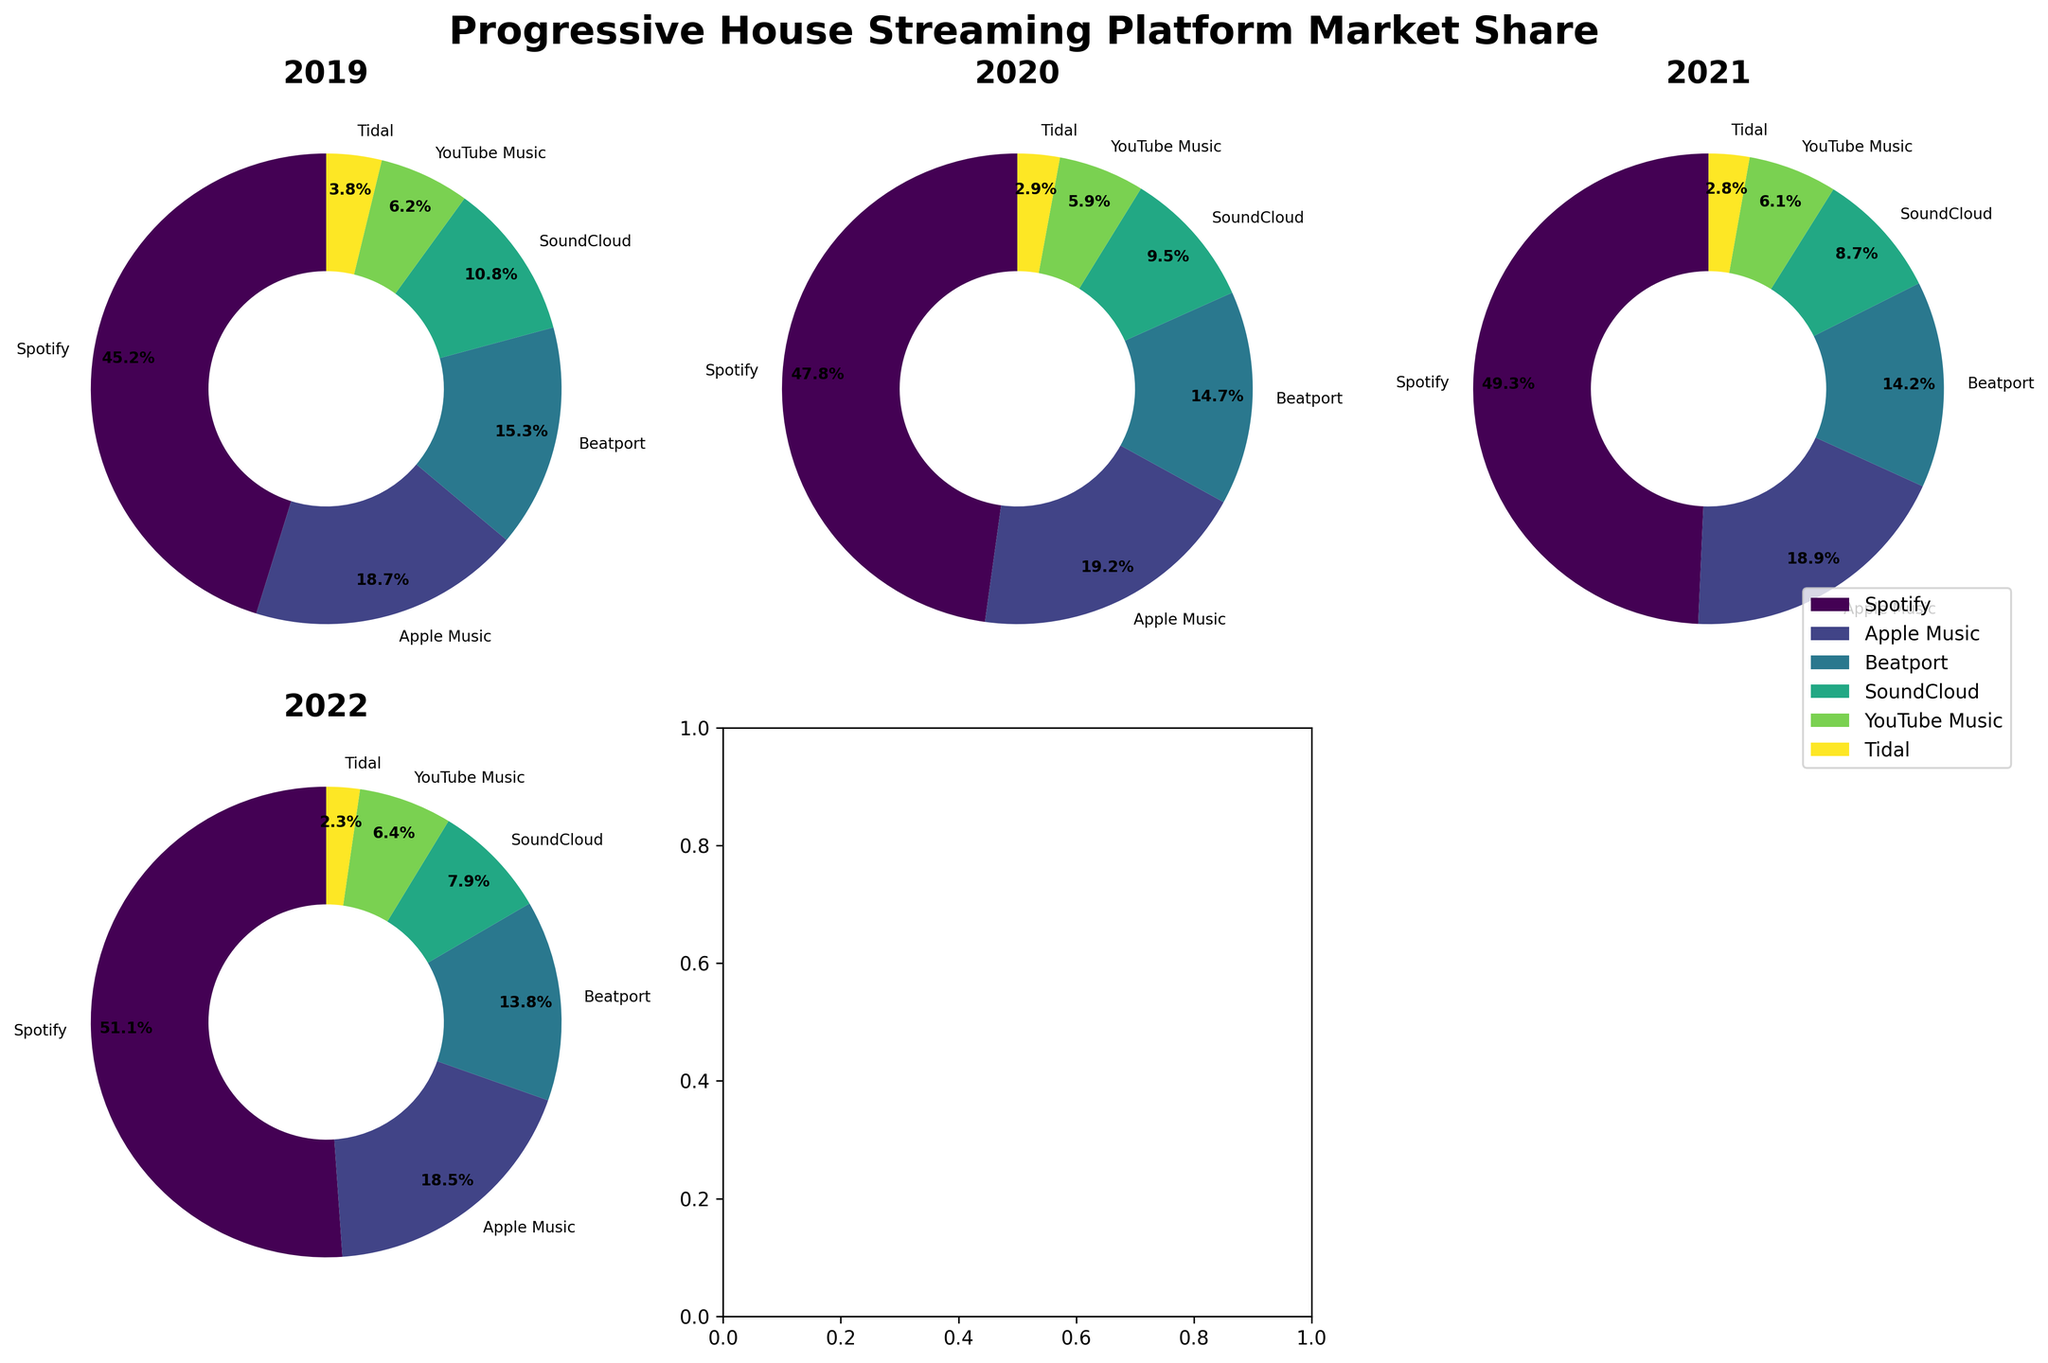How many platforms are displayed in each pie chart? Each pie chart has wedges corresponding to each platform. There are six labels around the pie charts, one for each platform.
Answer: Six Which year shows Spotify with the highest market share? Observing the title of each subplot and the wedge sizes, it's clear that Spotify has the largest wedge in the 2022 subplot.
Answer: 2022 Which platform shows a consistent decrease in market share over the years? By examining each subplot from 2019 to 2022, one can see that SoundCloud has wedges that decrease in size each year.
Answer: SoundCloud How much did Apple Music's market share change from 2019 to 2022? The market share for Apple Music in 2019 was 18.7%, and in 2022 it was 18.5%. The change is calculated by subtracting the latter from the former.
Answer: -0.2% Compare the market share of Tidal in 2019 and 2022, which year had a higher share? Observing the size of Tidal's wedges in the 2019 and 2022 subplots, it's clear that Tidal's wedge is larger in 2019.
Answer: 2019 Which platform has the smallest market share in 2022? Observing the wedges in the 2022 subplot, Tidal has the smallest wedge.
Answer: Tidal What is the trend for Beatport's market share from 2019 to 2022? Observing the pie charts, Beatport’s wedge size decreases every year from 2019 to 2022.
Answer: Decreasing What is the market share percentage difference between YouTube Music in 2019 and 2022? YouTube Music had a market share of 6.2% in 2019 and 6.4% in 2022. The difference is 6.4% - 6.2%.
Answer: 0.2% Which platform’s market share has remained relatively stable from 2019 to 2022? By carefully comparing the pie charts, Apple Music's wedges appear to have the least change in size over the years.
Answer: Apple Music Rank the platforms by their market share in 2020. Observing the 2020 subplot, the order from largest to smallest wedge: Spotify, Apple Music, Beatport, SoundCloud, YouTube Music, Tidal.
Answer: Spotify > Apple Music > Beatport > SoundCloud > YouTube Music > Tidal 